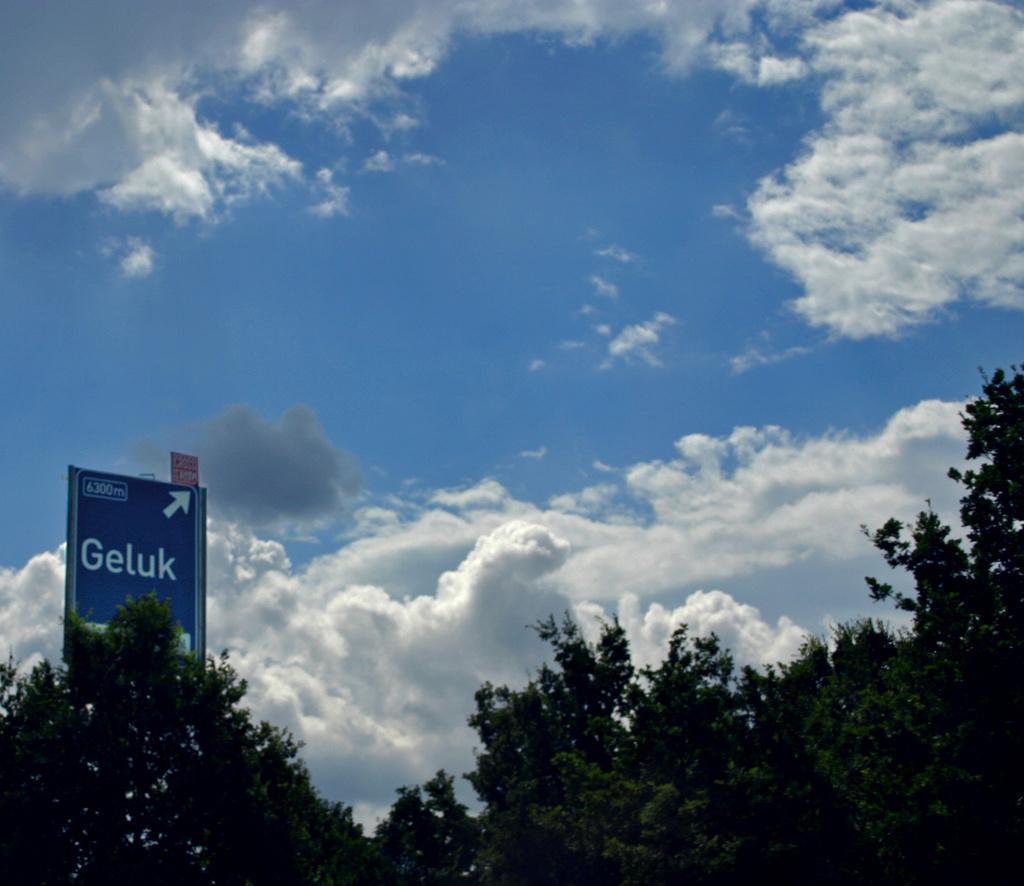Can you describe this image briefly? At the bottom of the picture there are trees and a hoarding. Sky is sunny. 